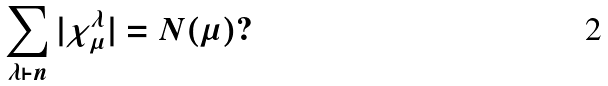<formula> <loc_0><loc_0><loc_500><loc_500>\sum _ { \lambda \vdash n } | \chi ^ { \lambda } _ { \mu } | = N ( \mu ) ?</formula> 